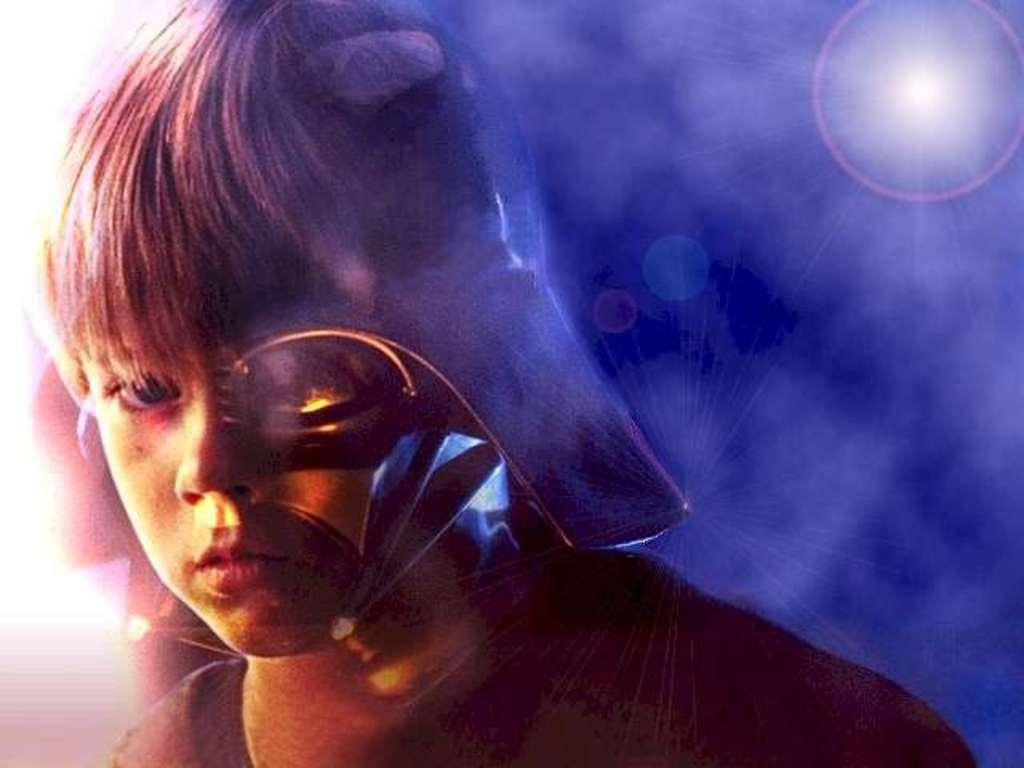What type of image is being described? The image is animated. Can you describe the person in the image? There is a person in the image, and they are on the left side. What else can be seen in the image besides the person? There is a light in the image. Where is the light located in the image? The light is on the top right. How many houses are visible in the image? There are no houses visible in the image; it is an animated scene with a person and a light. What type of tray is being used by the expert in the image? There is no expert or tray present in the image. 